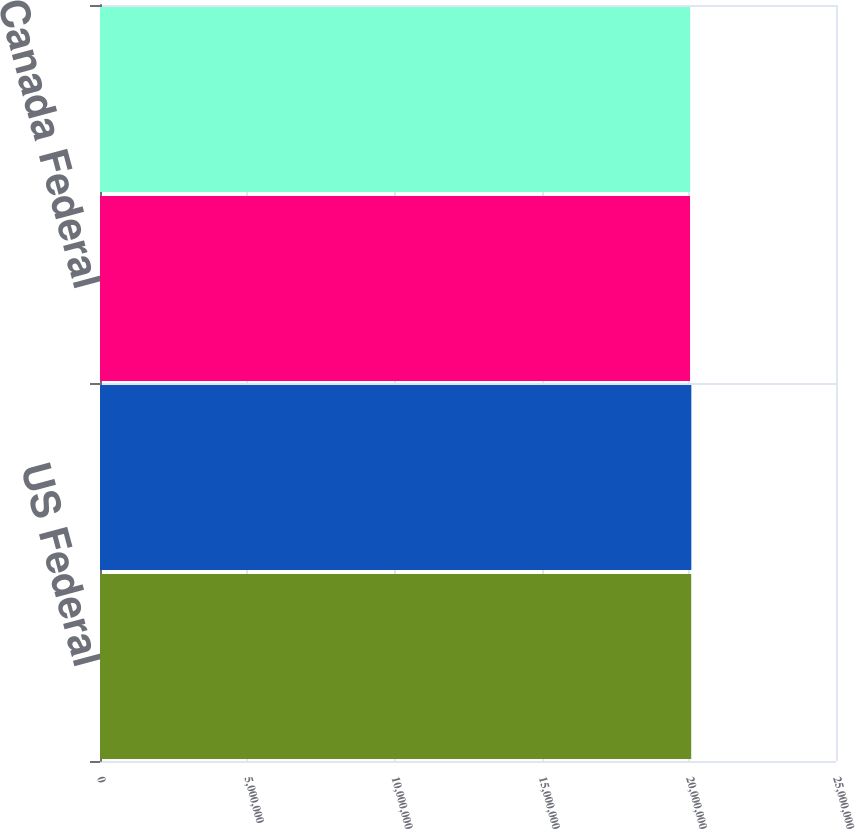<chart> <loc_0><loc_0><loc_500><loc_500><bar_chart><fcel>US Federal<fcel>Various US states<fcel>Canada Federal<fcel>Various Canadian provinces<nl><fcel>2.0082e+07<fcel>2.0086e+07<fcel>2.0042e+07<fcel>2.0046e+07<nl></chart> 